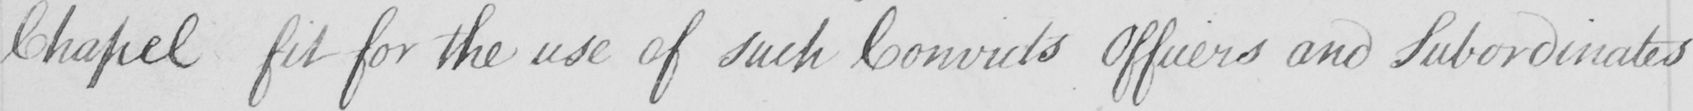Please provide the text content of this handwritten line. Chapel fit for the use of such Convicts Officers and Subordinates 